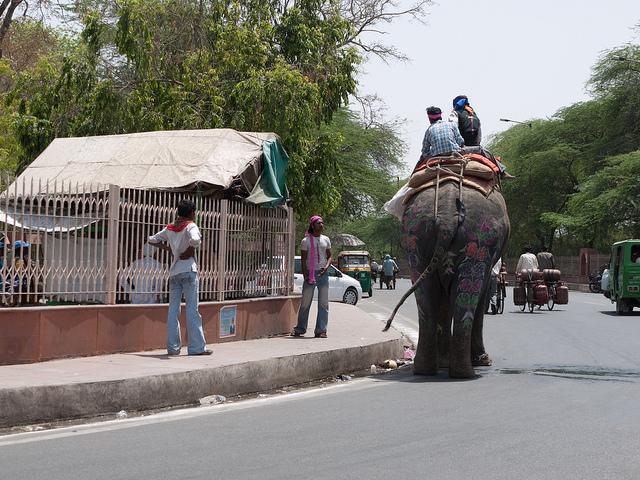How many people are on the elephant?
Give a very brief answer. 2. How many elephants do you see?
Give a very brief answer. 1. How many people are in the picture?
Give a very brief answer. 2. 